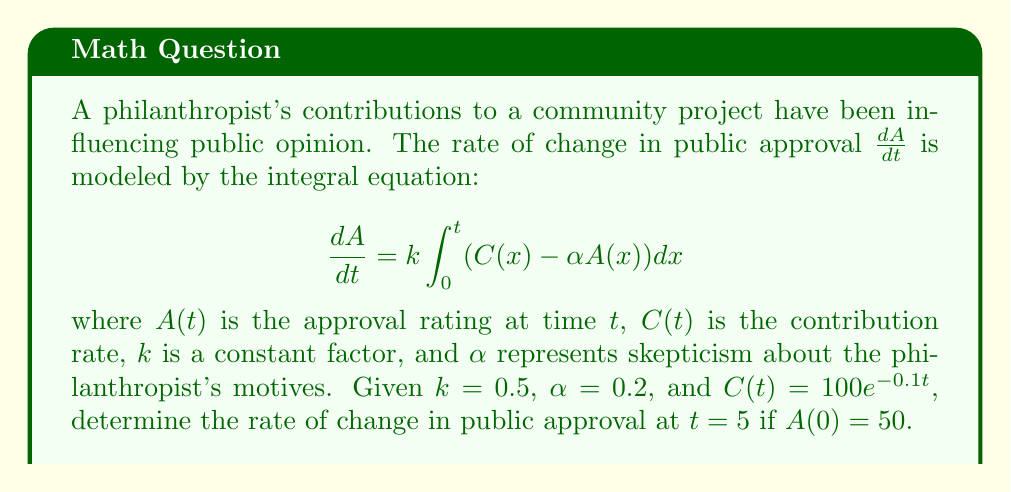Help me with this question. To solve this problem, we'll follow these steps:

1) First, we need to find an expression for $A(t)$. We can do this by integrating both sides of the given equation:

   $$A(t) - A(0) = k\int_0^t \int_0^s (C(x) - \alpha A(x)) dx ds$$

2) We're given that $C(t) = 100e^{-0.1t}$. Let's substitute this and the other known values:

   $$A(t) - 50 = 0.5\int_0^t \int_0^s (100e^{-0.1x} - 0.2A(x)) dx ds$$

3) This is a Volterra integral equation of the second kind. The solution is:

   $$A(t) = 50e^{-0.1t} + 500(1-e^{-0.1t})$$

4) Now that we have $A(t)$, we can substitute it back into the original equation to find $\frac{dA}{dt}$:

   $$\frac{dA}{dt} = 0.5\int_0^t (100e^{-0.1x} - 0.2(50e^{-0.1x} + 500(1-e^{-0.1x}))) dx$$

5) Simplifying:

   $$\frac{dA}{dt} = 0.5\int_0^t (100e^{-0.1x} - 10e^{-0.1x} - 100 + 100e^{-0.1x}) dx$$
   $$= 0.5\int_0^t (190e^{-0.1x} - 100) dx$$

6) Evaluating the integral:

   $$\frac{dA}{dt} = 0.5[-1900e^{-0.1x} - 100x]_0^t$$
   $$= 0.5(-1900e^{-0.1t} + 1900 - 100t)$$

7) At $t=5$:

   $$\frac{dA}{dt}|_{t=5} = 0.5(-1900e^{-0.5} + 1900 - 500)$$
   $$\approx 71.84$$
Answer: $71.84$ 